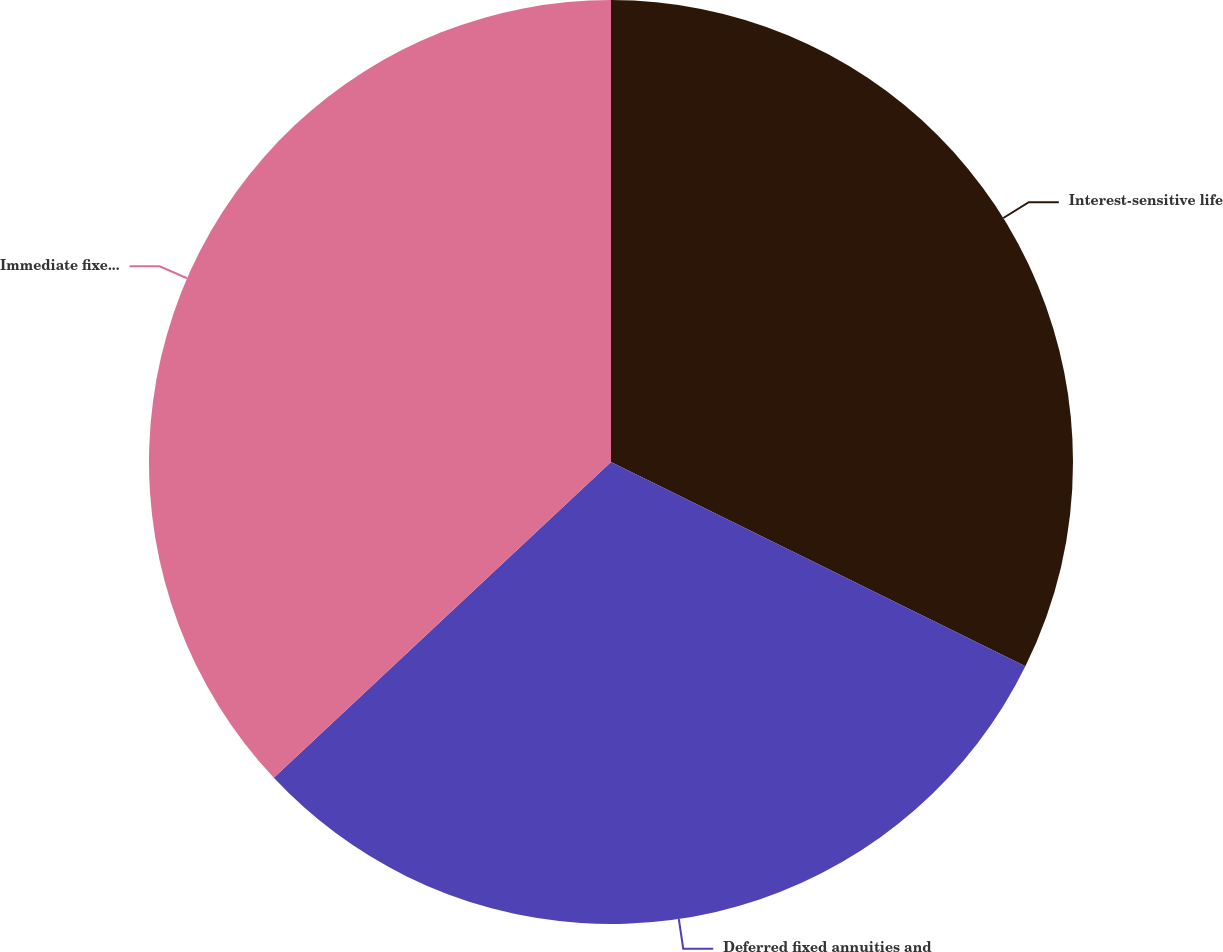Convert chart to OTSL. <chart><loc_0><loc_0><loc_500><loc_500><pie_chart><fcel>Interest-sensitive life<fcel>Deferred fixed annuities and<fcel>Immediate fixed annuities with<nl><fcel>32.29%<fcel>30.73%<fcel>36.98%<nl></chart> 